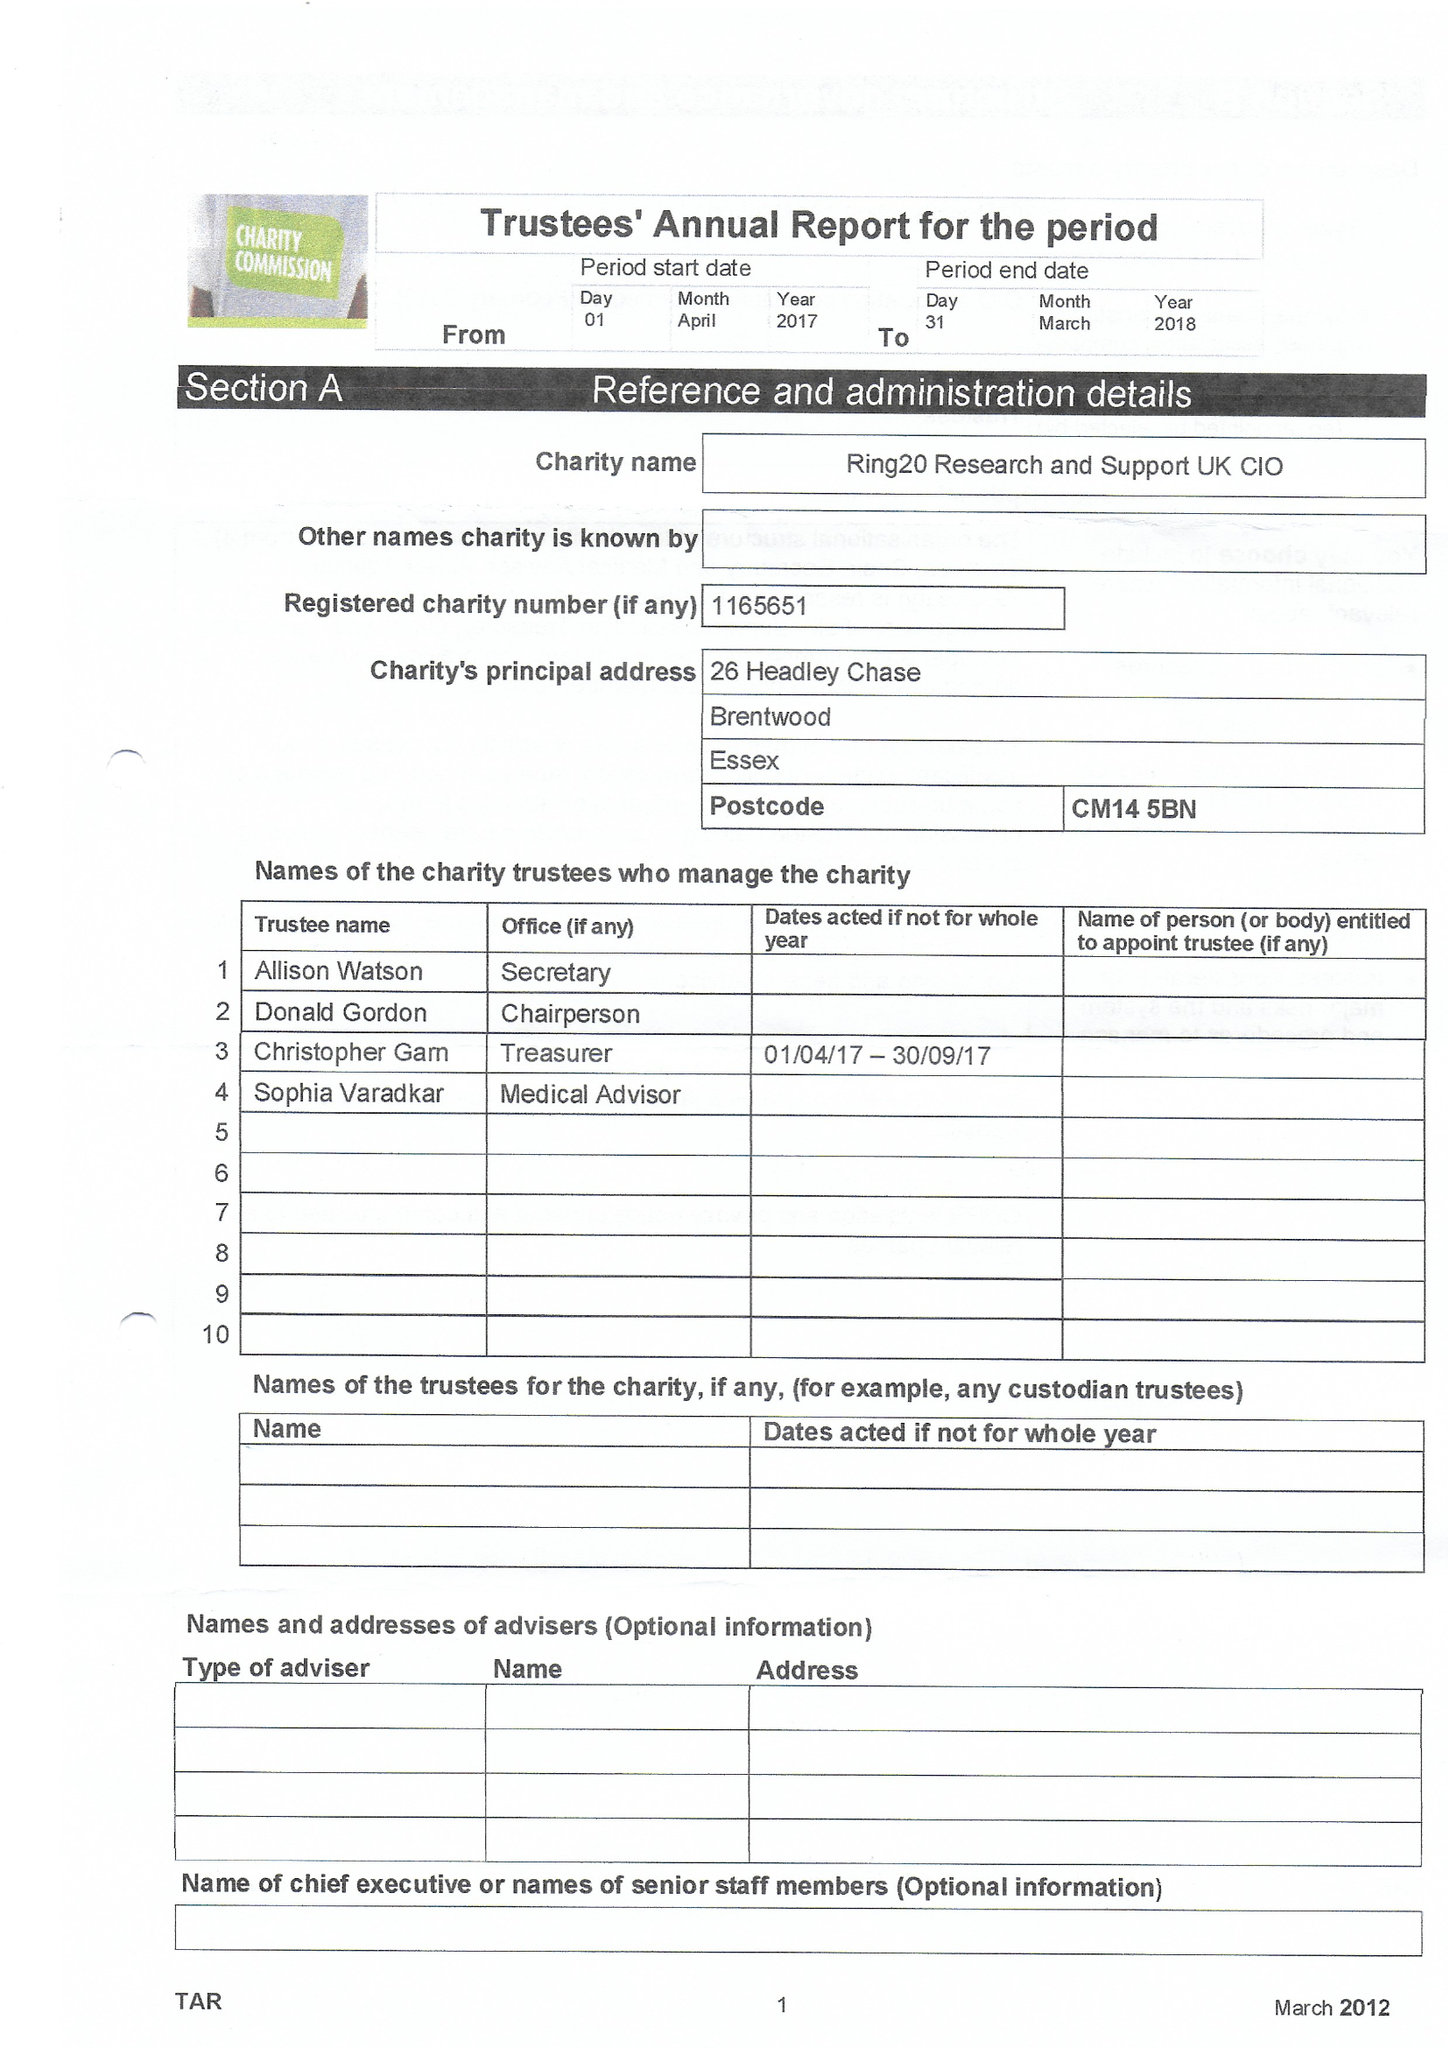What is the value for the address__street_line?
Answer the question using a single word or phrase. 26 HEADLEY CHASE 